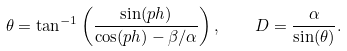Convert formula to latex. <formula><loc_0><loc_0><loc_500><loc_500>\theta = \tan ^ { - 1 } \left ( \frac { \sin ( p h ) } { \cos ( p h ) - \beta / \alpha } \right ) , \quad D = \frac { \alpha } { \sin ( \theta ) } .</formula> 